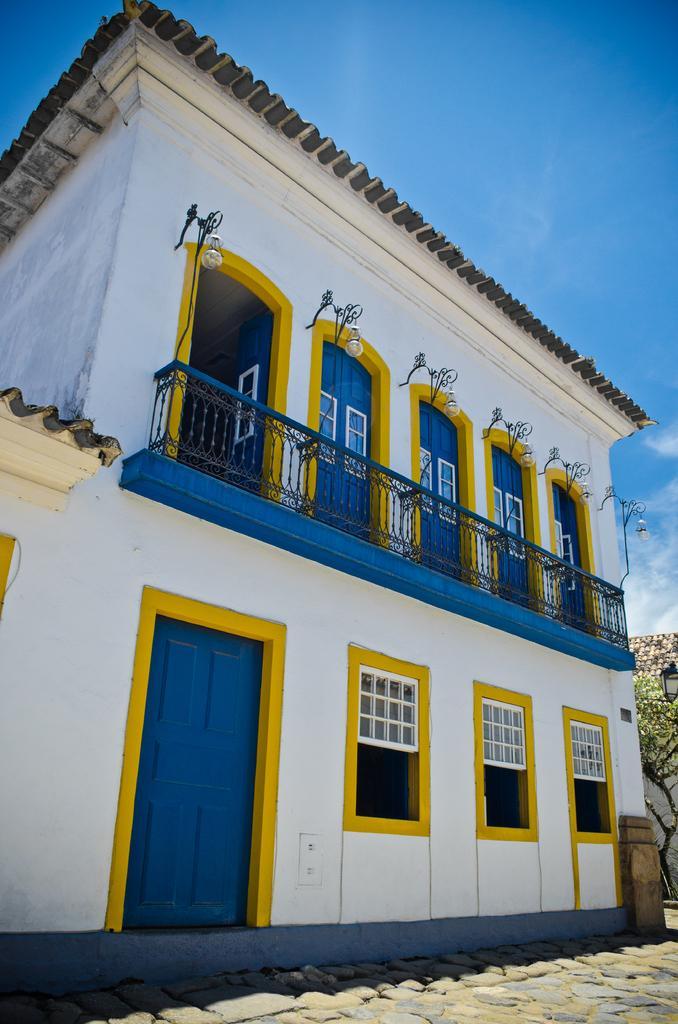Describe this image in one or two sentences. In this image I can see the building, windows, railing, doors, lights, trees and the sky is in blue and white color. 